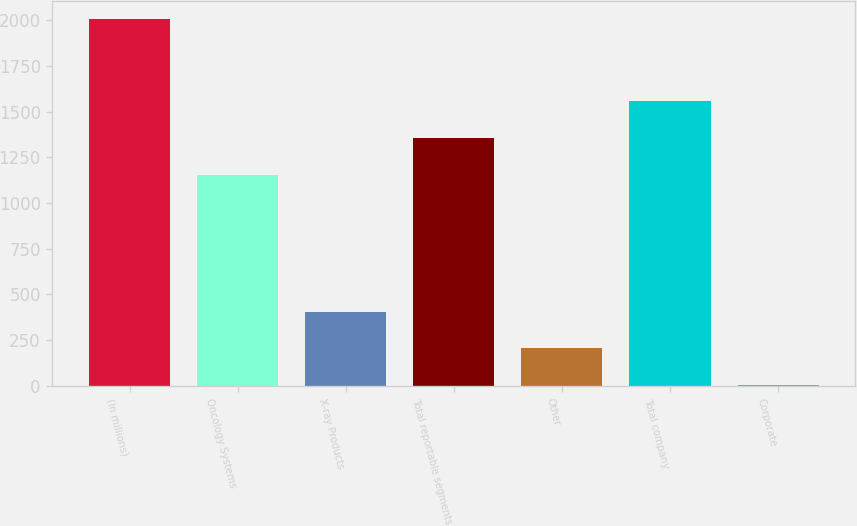Convert chart to OTSL. <chart><loc_0><loc_0><loc_500><loc_500><bar_chart><fcel>(In millions)<fcel>Oncology Systems<fcel>X-ray Products<fcel>Total reportable segments<fcel>Other<fcel>Total company<fcel>Corporate<nl><fcel>2005<fcel>1156<fcel>405<fcel>1356<fcel>205<fcel>1556<fcel>5<nl></chart> 